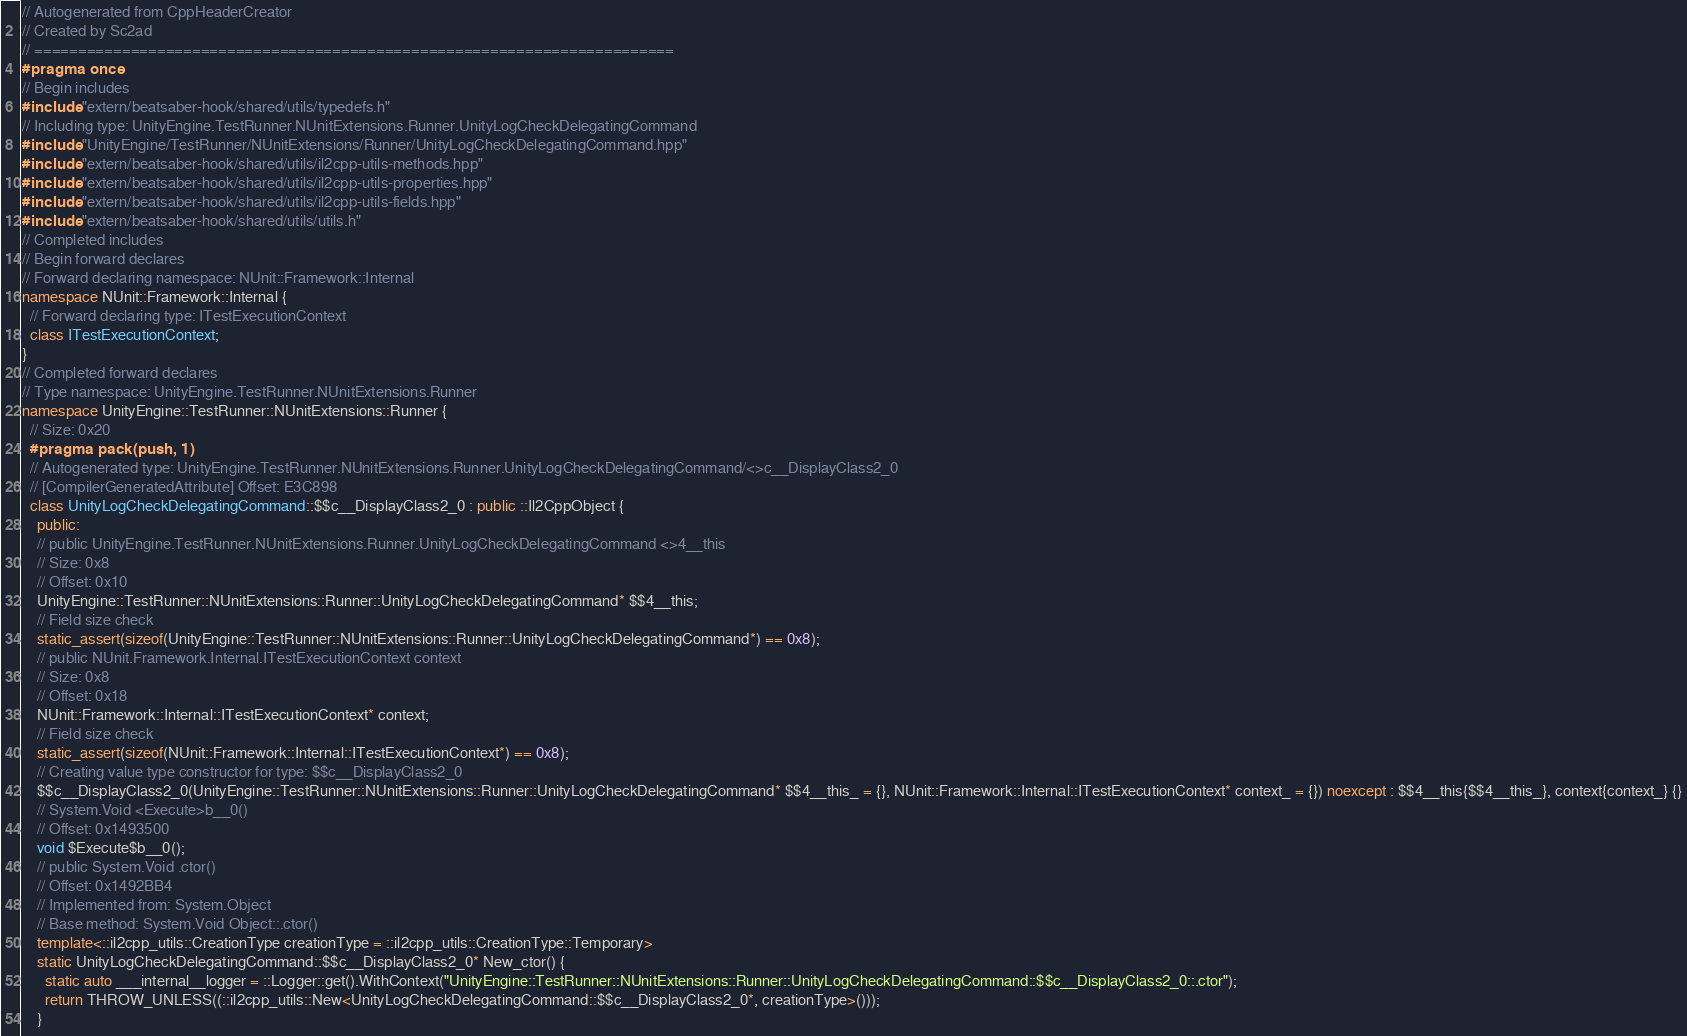<code> <loc_0><loc_0><loc_500><loc_500><_C++_>// Autogenerated from CppHeaderCreator
// Created by Sc2ad
// =========================================================================
#pragma once
// Begin includes
#include "extern/beatsaber-hook/shared/utils/typedefs.h"
// Including type: UnityEngine.TestRunner.NUnitExtensions.Runner.UnityLogCheckDelegatingCommand
#include "UnityEngine/TestRunner/NUnitExtensions/Runner/UnityLogCheckDelegatingCommand.hpp"
#include "extern/beatsaber-hook/shared/utils/il2cpp-utils-methods.hpp"
#include "extern/beatsaber-hook/shared/utils/il2cpp-utils-properties.hpp"
#include "extern/beatsaber-hook/shared/utils/il2cpp-utils-fields.hpp"
#include "extern/beatsaber-hook/shared/utils/utils.h"
// Completed includes
// Begin forward declares
// Forward declaring namespace: NUnit::Framework::Internal
namespace NUnit::Framework::Internal {
  // Forward declaring type: ITestExecutionContext
  class ITestExecutionContext;
}
// Completed forward declares
// Type namespace: UnityEngine.TestRunner.NUnitExtensions.Runner
namespace UnityEngine::TestRunner::NUnitExtensions::Runner {
  // Size: 0x20
  #pragma pack(push, 1)
  // Autogenerated type: UnityEngine.TestRunner.NUnitExtensions.Runner.UnityLogCheckDelegatingCommand/<>c__DisplayClass2_0
  // [CompilerGeneratedAttribute] Offset: E3C898
  class UnityLogCheckDelegatingCommand::$$c__DisplayClass2_0 : public ::Il2CppObject {
    public:
    // public UnityEngine.TestRunner.NUnitExtensions.Runner.UnityLogCheckDelegatingCommand <>4__this
    // Size: 0x8
    // Offset: 0x10
    UnityEngine::TestRunner::NUnitExtensions::Runner::UnityLogCheckDelegatingCommand* $$4__this;
    // Field size check
    static_assert(sizeof(UnityEngine::TestRunner::NUnitExtensions::Runner::UnityLogCheckDelegatingCommand*) == 0x8);
    // public NUnit.Framework.Internal.ITestExecutionContext context
    // Size: 0x8
    // Offset: 0x18
    NUnit::Framework::Internal::ITestExecutionContext* context;
    // Field size check
    static_assert(sizeof(NUnit::Framework::Internal::ITestExecutionContext*) == 0x8);
    // Creating value type constructor for type: $$c__DisplayClass2_0
    $$c__DisplayClass2_0(UnityEngine::TestRunner::NUnitExtensions::Runner::UnityLogCheckDelegatingCommand* $$4__this_ = {}, NUnit::Framework::Internal::ITestExecutionContext* context_ = {}) noexcept : $$4__this{$$4__this_}, context{context_} {}
    // System.Void <Execute>b__0()
    // Offset: 0x1493500
    void $Execute$b__0();
    // public System.Void .ctor()
    // Offset: 0x1492BB4
    // Implemented from: System.Object
    // Base method: System.Void Object::.ctor()
    template<::il2cpp_utils::CreationType creationType = ::il2cpp_utils::CreationType::Temporary>
    static UnityLogCheckDelegatingCommand::$$c__DisplayClass2_0* New_ctor() {
      static auto ___internal__logger = ::Logger::get().WithContext("UnityEngine::TestRunner::NUnitExtensions::Runner::UnityLogCheckDelegatingCommand::$$c__DisplayClass2_0::.ctor");
      return THROW_UNLESS((::il2cpp_utils::New<UnityLogCheckDelegatingCommand::$$c__DisplayClass2_0*, creationType>()));
    }</code> 